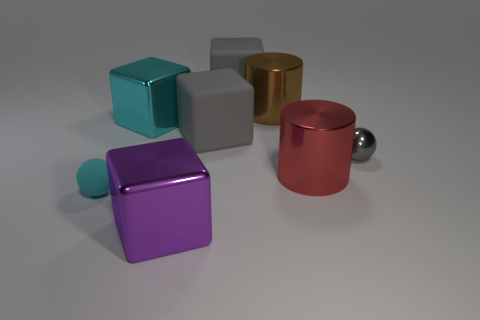Add 1 small cyan matte things. How many objects exist? 9 Subtract all purple blocks. How many blocks are left? 3 Subtract all green spheres. How many gray blocks are left? 2 Subtract all spheres. How many objects are left? 6 Subtract all purple blocks. How many blocks are left? 3 Subtract 3 blocks. How many blocks are left? 1 Add 7 large gray things. How many large gray things are left? 9 Add 8 cyan metallic blocks. How many cyan metallic blocks exist? 9 Subtract 1 cyan spheres. How many objects are left? 7 Subtract all red cylinders. Subtract all cyan cubes. How many cylinders are left? 1 